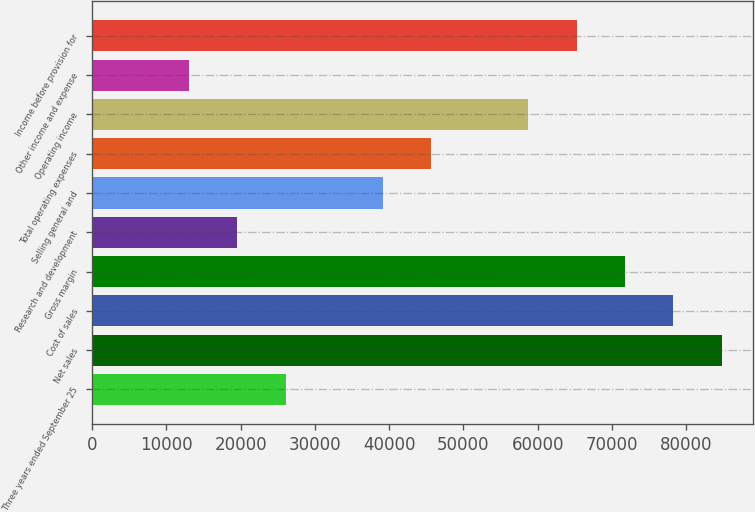Convert chart to OTSL. <chart><loc_0><loc_0><loc_500><loc_500><bar_chart><fcel>Three years ended September 25<fcel>Net sales<fcel>Cost of sales<fcel>Gross margin<fcel>Research and development<fcel>Selling general and<fcel>Total operating expenses<fcel>Operating income<fcel>Other income and expense<fcel>Income before provision for<nl><fcel>26099.1<fcel>84788<fcel>78267<fcel>71746<fcel>19578.1<fcel>39141.1<fcel>45662.1<fcel>58704<fcel>13057.1<fcel>65225<nl></chart> 